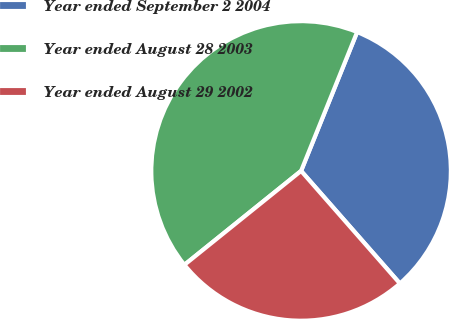Convert chart. <chart><loc_0><loc_0><loc_500><loc_500><pie_chart><fcel>Year ended September 2 2004<fcel>Year ended August 28 2003<fcel>Year ended August 29 2002<nl><fcel>32.43%<fcel>41.89%<fcel>25.68%<nl></chart> 